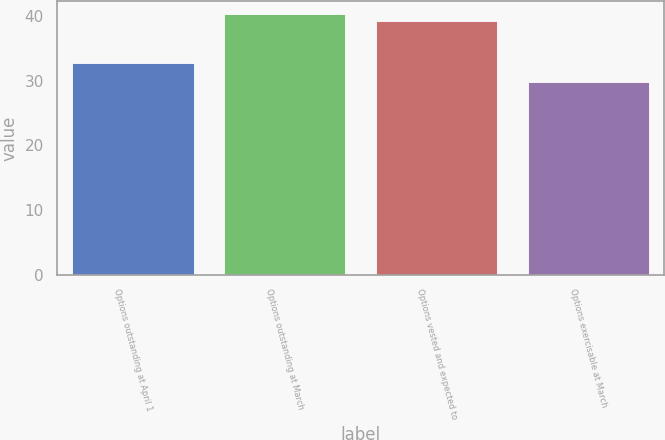Convert chart to OTSL. <chart><loc_0><loc_0><loc_500><loc_500><bar_chart><fcel>Options outstanding at April 1<fcel>Options outstanding at March<fcel>Options vested and expected to<fcel>Options exercisable at March<nl><fcel>32.79<fcel>40.29<fcel>39.28<fcel>29.81<nl></chart> 